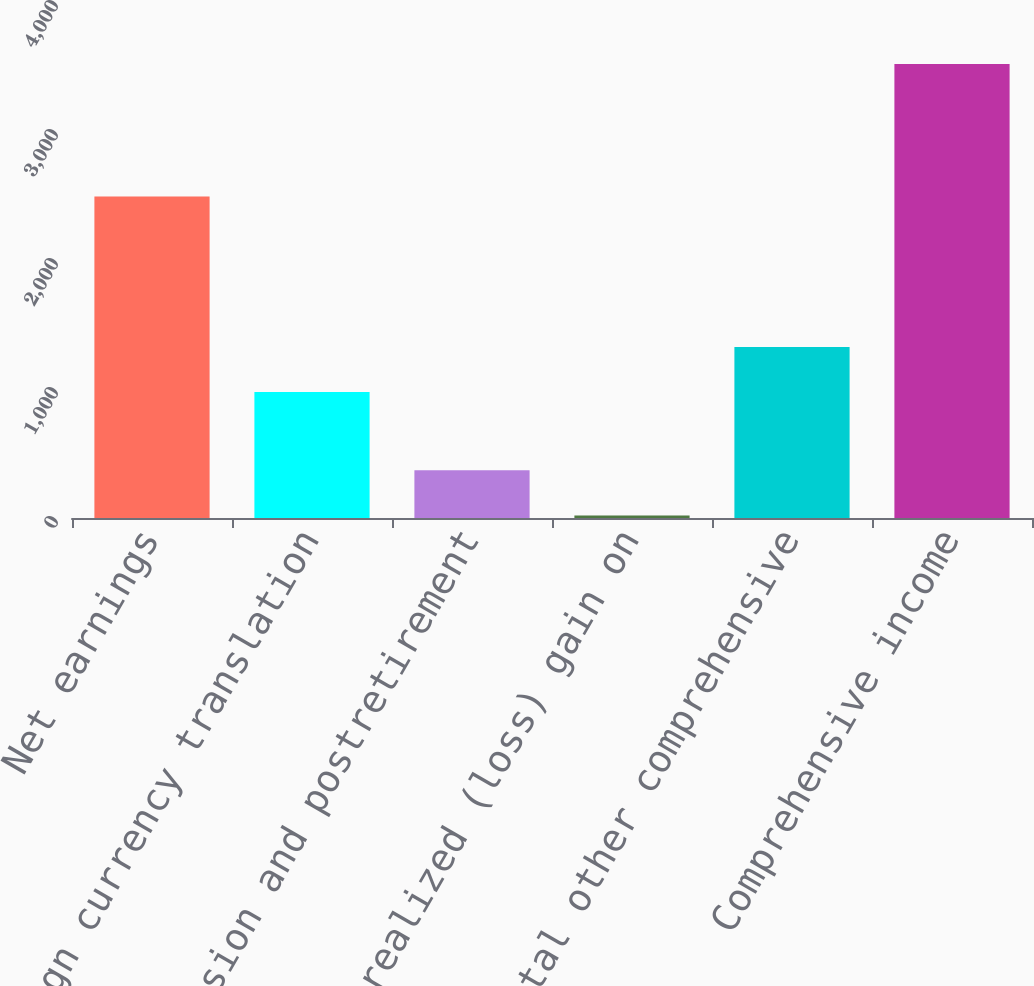<chart> <loc_0><loc_0><loc_500><loc_500><bar_chart><fcel>Net earnings<fcel>Foreign currency translation<fcel>Pension and postretirement<fcel>Unrealized (loss) gain on<fcel>Total other comprehensive<fcel>Comprehensive income<nl><fcel>2492.1<fcel>976.1<fcel>369.6<fcel>19.6<fcel>1326.1<fcel>3519.6<nl></chart> 